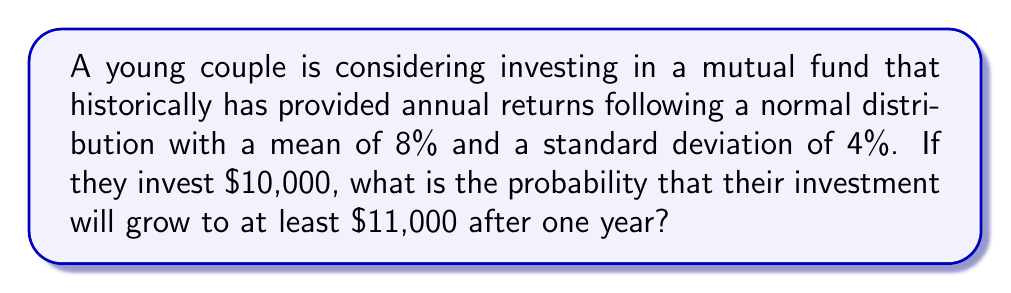Can you solve this math problem? Let's approach this step-by-step:

1) First, we need to calculate the percentage return that would result in $11,000 from a $10,000 investment:

   $$\frac{11000 - 10000}{10000} \times 100\% = 10\%$$

2) Now, we need to find the probability that the return will be at least 10%.

3) We know that the returns follow a normal distribution with mean $\mu = 8\%$ and standard deviation $\sigma = 4\%$.

4) To use the standard normal distribution, we need to calculate the z-score:

   $$z = \frac{x - \mu}{\sigma} = \frac{10\% - 8\%}{4\%} = 0.5$$

5) We want the probability of the return being greater than 10%, which is equivalent to $P(Z > 0.5)$ where Z is the standard normal variable.

6) Using a standard normal table or calculator, we can find:

   $$P(Z > 0.5) = 1 - P(Z < 0.5) = 1 - 0.6915 = 0.3085$$

Therefore, the probability that their investment will grow to at least $11,000 after one year is approximately 0.3085 or 30.85%.
Answer: The probability is approximately 0.3085 or 30.85%. 